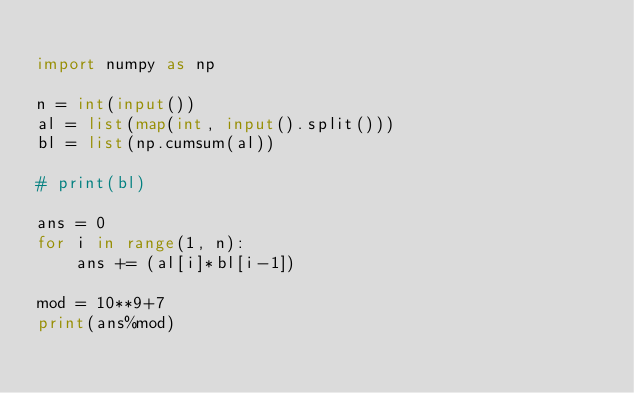Convert code to text. <code><loc_0><loc_0><loc_500><loc_500><_Python_>
import numpy as np

n = int(input())
al = list(map(int, input().split()))
bl = list(np.cumsum(al))

# print(bl)

ans = 0
for i in range(1, n):
    ans += (al[i]*bl[i-1])

mod = 10**9+7
print(ans%mod)</code> 